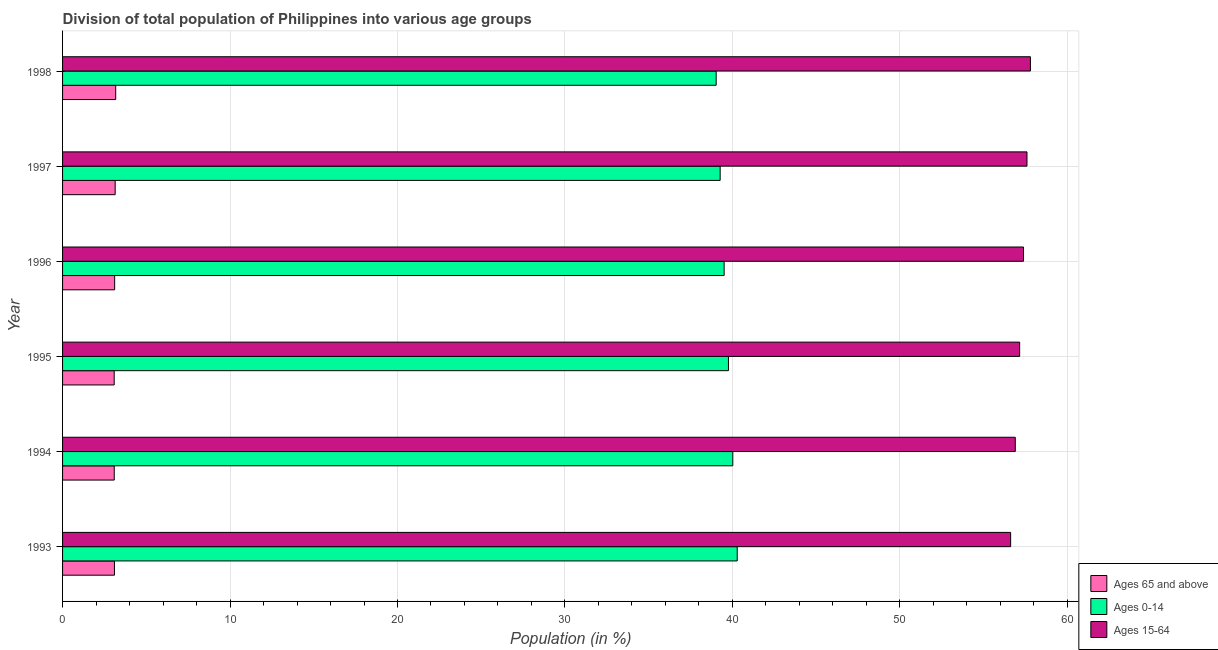How many different coloured bars are there?
Your answer should be very brief. 3. How many groups of bars are there?
Your answer should be very brief. 6. How many bars are there on the 1st tick from the top?
Your response must be concise. 3. How many bars are there on the 4th tick from the bottom?
Give a very brief answer. 3. What is the percentage of population within the age-group 15-64 in 1995?
Offer a very short reply. 57.15. Across all years, what is the maximum percentage of population within the age-group of 65 and above?
Offer a terse response. 3.17. Across all years, what is the minimum percentage of population within the age-group 0-14?
Offer a terse response. 39.03. In which year was the percentage of population within the age-group of 65 and above maximum?
Your answer should be compact. 1998. What is the total percentage of population within the age-group of 65 and above in the graph?
Give a very brief answer. 18.69. What is the difference between the percentage of population within the age-group 0-14 in 1994 and that in 1997?
Offer a terse response. 0.76. What is the difference between the percentage of population within the age-group 0-14 in 1998 and the percentage of population within the age-group of 65 and above in 1996?
Your response must be concise. 35.92. What is the average percentage of population within the age-group 0-14 per year?
Provide a succinct answer. 39.65. In the year 1995, what is the difference between the percentage of population within the age-group 0-14 and percentage of population within the age-group 15-64?
Offer a terse response. -17.39. In how many years, is the percentage of population within the age-group 15-64 greater than 54 %?
Your answer should be compact. 6. What is the ratio of the percentage of population within the age-group 15-64 in 1996 to that in 1998?
Provide a succinct answer. 0.99. Is the percentage of population within the age-group of 65 and above in 1993 less than that in 1995?
Your response must be concise. No. What is the difference between the highest and the second highest percentage of population within the age-group of 65 and above?
Provide a succinct answer. 0.03. What is the difference between the highest and the lowest percentage of population within the age-group of 65 and above?
Give a very brief answer. 0.09. Is the sum of the percentage of population within the age-group of 65 and above in 1996 and 1997 greater than the maximum percentage of population within the age-group 0-14 across all years?
Offer a very short reply. No. What does the 3rd bar from the top in 1994 represents?
Give a very brief answer. Ages 65 and above. What does the 2nd bar from the bottom in 1993 represents?
Your answer should be compact. Ages 0-14. What is the difference between two consecutive major ticks on the X-axis?
Keep it short and to the point. 10. Are the values on the major ticks of X-axis written in scientific E-notation?
Your response must be concise. No. Does the graph contain any zero values?
Offer a terse response. No. Where does the legend appear in the graph?
Provide a succinct answer. Bottom right. How many legend labels are there?
Ensure brevity in your answer.  3. What is the title of the graph?
Offer a terse response. Division of total population of Philippines into various age groups
. Does "Tertiary education" appear as one of the legend labels in the graph?
Your response must be concise. No. What is the label or title of the X-axis?
Keep it short and to the point. Population (in %). What is the label or title of the Y-axis?
Make the answer very short. Year. What is the Population (in %) of Ages 65 and above in 1993?
Offer a terse response. 3.1. What is the Population (in %) of Ages 0-14 in 1993?
Your answer should be compact. 40.29. What is the Population (in %) of Ages 15-64 in 1993?
Your answer should be very brief. 56.61. What is the Population (in %) in Ages 65 and above in 1994?
Keep it short and to the point. 3.09. What is the Population (in %) of Ages 0-14 in 1994?
Provide a succinct answer. 40.02. What is the Population (in %) of Ages 15-64 in 1994?
Provide a short and direct response. 56.89. What is the Population (in %) in Ages 65 and above in 1995?
Your response must be concise. 3.08. What is the Population (in %) of Ages 0-14 in 1995?
Your answer should be compact. 39.76. What is the Population (in %) in Ages 15-64 in 1995?
Ensure brevity in your answer.  57.15. What is the Population (in %) of Ages 65 and above in 1996?
Your answer should be very brief. 3.11. What is the Population (in %) of Ages 0-14 in 1996?
Your response must be concise. 39.51. What is the Population (in %) of Ages 15-64 in 1996?
Keep it short and to the point. 57.38. What is the Population (in %) of Ages 65 and above in 1997?
Your answer should be compact. 3.14. What is the Population (in %) of Ages 0-14 in 1997?
Provide a short and direct response. 39.27. What is the Population (in %) in Ages 15-64 in 1997?
Offer a terse response. 57.59. What is the Population (in %) in Ages 65 and above in 1998?
Keep it short and to the point. 3.17. What is the Population (in %) in Ages 0-14 in 1998?
Your answer should be compact. 39.03. What is the Population (in %) in Ages 15-64 in 1998?
Your response must be concise. 57.8. Across all years, what is the maximum Population (in %) in Ages 65 and above?
Provide a succinct answer. 3.17. Across all years, what is the maximum Population (in %) of Ages 0-14?
Offer a very short reply. 40.29. Across all years, what is the maximum Population (in %) of Ages 15-64?
Your answer should be compact. 57.8. Across all years, what is the minimum Population (in %) in Ages 65 and above?
Your answer should be very brief. 3.08. Across all years, what is the minimum Population (in %) in Ages 0-14?
Make the answer very short. 39.03. Across all years, what is the minimum Population (in %) in Ages 15-64?
Make the answer very short. 56.61. What is the total Population (in %) of Ages 65 and above in the graph?
Provide a short and direct response. 18.69. What is the total Population (in %) of Ages 0-14 in the graph?
Offer a terse response. 237.88. What is the total Population (in %) in Ages 15-64 in the graph?
Offer a terse response. 343.43. What is the difference between the Population (in %) of Ages 65 and above in 1993 and that in 1994?
Provide a succinct answer. 0.01. What is the difference between the Population (in %) in Ages 0-14 in 1993 and that in 1994?
Your answer should be compact. 0.26. What is the difference between the Population (in %) in Ages 15-64 in 1993 and that in 1994?
Provide a succinct answer. -0.28. What is the difference between the Population (in %) of Ages 65 and above in 1993 and that in 1995?
Offer a very short reply. 0.02. What is the difference between the Population (in %) of Ages 0-14 in 1993 and that in 1995?
Offer a terse response. 0.52. What is the difference between the Population (in %) of Ages 15-64 in 1993 and that in 1995?
Ensure brevity in your answer.  -0.54. What is the difference between the Population (in %) in Ages 65 and above in 1993 and that in 1996?
Provide a succinct answer. -0.01. What is the difference between the Population (in %) of Ages 0-14 in 1993 and that in 1996?
Your response must be concise. 0.78. What is the difference between the Population (in %) of Ages 15-64 in 1993 and that in 1996?
Your answer should be compact. -0.77. What is the difference between the Population (in %) of Ages 65 and above in 1993 and that in 1997?
Offer a terse response. -0.04. What is the difference between the Population (in %) of Ages 0-14 in 1993 and that in 1997?
Ensure brevity in your answer.  1.02. What is the difference between the Population (in %) in Ages 15-64 in 1993 and that in 1997?
Your answer should be compact. -0.98. What is the difference between the Population (in %) in Ages 65 and above in 1993 and that in 1998?
Make the answer very short. -0.07. What is the difference between the Population (in %) in Ages 0-14 in 1993 and that in 1998?
Offer a very short reply. 1.26. What is the difference between the Population (in %) in Ages 15-64 in 1993 and that in 1998?
Offer a very short reply. -1.18. What is the difference between the Population (in %) in Ages 65 and above in 1994 and that in 1995?
Give a very brief answer. 0. What is the difference between the Population (in %) in Ages 0-14 in 1994 and that in 1995?
Offer a very short reply. 0.26. What is the difference between the Population (in %) in Ages 15-64 in 1994 and that in 1995?
Offer a very short reply. -0.26. What is the difference between the Population (in %) of Ages 65 and above in 1994 and that in 1996?
Offer a terse response. -0.02. What is the difference between the Population (in %) in Ages 0-14 in 1994 and that in 1996?
Offer a very short reply. 0.52. What is the difference between the Population (in %) of Ages 15-64 in 1994 and that in 1996?
Ensure brevity in your answer.  -0.49. What is the difference between the Population (in %) of Ages 65 and above in 1994 and that in 1997?
Give a very brief answer. -0.06. What is the difference between the Population (in %) of Ages 0-14 in 1994 and that in 1997?
Keep it short and to the point. 0.75. What is the difference between the Population (in %) in Ages 15-64 in 1994 and that in 1997?
Your answer should be compact. -0.7. What is the difference between the Population (in %) of Ages 65 and above in 1994 and that in 1998?
Make the answer very short. -0.09. What is the difference between the Population (in %) in Ages 15-64 in 1994 and that in 1998?
Your answer should be very brief. -0.9. What is the difference between the Population (in %) of Ages 65 and above in 1995 and that in 1996?
Keep it short and to the point. -0.03. What is the difference between the Population (in %) in Ages 0-14 in 1995 and that in 1996?
Your response must be concise. 0.26. What is the difference between the Population (in %) in Ages 15-64 in 1995 and that in 1996?
Keep it short and to the point. -0.23. What is the difference between the Population (in %) in Ages 65 and above in 1995 and that in 1997?
Offer a very short reply. -0.06. What is the difference between the Population (in %) in Ages 0-14 in 1995 and that in 1997?
Your answer should be very brief. 0.5. What is the difference between the Population (in %) of Ages 15-64 in 1995 and that in 1997?
Ensure brevity in your answer.  -0.44. What is the difference between the Population (in %) of Ages 65 and above in 1995 and that in 1998?
Offer a terse response. -0.09. What is the difference between the Population (in %) in Ages 0-14 in 1995 and that in 1998?
Ensure brevity in your answer.  0.73. What is the difference between the Population (in %) in Ages 15-64 in 1995 and that in 1998?
Ensure brevity in your answer.  -0.64. What is the difference between the Population (in %) of Ages 65 and above in 1996 and that in 1997?
Make the answer very short. -0.03. What is the difference between the Population (in %) in Ages 0-14 in 1996 and that in 1997?
Ensure brevity in your answer.  0.24. What is the difference between the Population (in %) in Ages 15-64 in 1996 and that in 1997?
Your answer should be very brief. -0.21. What is the difference between the Population (in %) in Ages 65 and above in 1996 and that in 1998?
Ensure brevity in your answer.  -0.06. What is the difference between the Population (in %) in Ages 0-14 in 1996 and that in 1998?
Give a very brief answer. 0.48. What is the difference between the Population (in %) in Ages 15-64 in 1996 and that in 1998?
Offer a very short reply. -0.41. What is the difference between the Population (in %) in Ages 65 and above in 1997 and that in 1998?
Give a very brief answer. -0.03. What is the difference between the Population (in %) in Ages 0-14 in 1997 and that in 1998?
Your answer should be compact. 0.24. What is the difference between the Population (in %) of Ages 15-64 in 1997 and that in 1998?
Your answer should be very brief. -0.21. What is the difference between the Population (in %) of Ages 65 and above in 1993 and the Population (in %) of Ages 0-14 in 1994?
Your answer should be very brief. -36.92. What is the difference between the Population (in %) in Ages 65 and above in 1993 and the Population (in %) in Ages 15-64 in 1994?
Offer a terse response. -53.79. What is the difference between the Population (in %) in Ages 0-14 in 1993 and the Population (in %) in Ages 15-64 in 1994?
Your response must be concise. -16.6. What is the difference between the Population (in %) in Ages 65 and above in 1993 and the Population (in %) in Ages 0-14 in 1995?
Your answer should be very brief. -36.66. What is the difference between the Population (in %) in Ages 65 and above in 1993 and the Population (in %) in Ages 15-64 in 1995?
Offer a very short reply. -54.05. What is the difference between the Population (in %) of Ages 0-14 in 1993 and the Population (in %) of Ages 15-64 in 1995?
Give a very brief answer. -16.87. What is the difference between the Population (in %) of Ages 65 and above in 1993 and the Population (in %) of Ages 0-14 in 1996?
Provide a succinct answer. -36.41. What is the difference between the Population (in %) in Ages 65 and above in 1993 and the Population (in %) in Ages 15-64 in 1996?
Your response must be concise. -54.28. What is the difference between the Population (in %) of Ages 0-14 in 1993 and the Population (in %) of Ages 15-64 in 1996?
Offer a terse response. -17.1. What is the difference between the Population (in %) in Ages 65 and above in 1993 and the Population (in %) in Ages 0-14 in 1997?
Keep it short and to the point. -36.17. What is the difference between the Population (in %) in Ages 65 and above in 1993 and the Population (in %) in Ages 15-64 in 1997?
Your answer should be compact. -54.49. What is the difference between the Population (in %) in Ages 0-14 in 1993 and the Population (in %) in Ages 15-64 in 1997?
Provide a succinct answer. -17.3. What is the difference between the Population (in %) of Ages 65 and above in 1993 and the Population (in %) of Ages 0-14 in 1998?
Offer a very short reply. -35.93. What is the difference between the Population (in %) of Ages 65 and above in 1993 and the Population (in %) of Ages 15-64 in 1998?
Your answer should be compact. -54.7. What is the difference between the Population (in %) in Ages 0-14 in 1993 and the Population (in %) in Ages 15-64 in 1998?
Give a very brief answer. -17.51. What is the difference between the Population (in %) in Ages 65 and above in 1994 and the Population (in %) in Ages 0-14 in 1995?
Provide a short and direct response. -36.68. What is the difference between the Population (in %) in Ages 65 and above in 1994 and the Population (in %) in Ages 15-64 in 1995?
Your answer should be very brief. -54.07. What is the difference between the Population (in %) in Ages 0-14 in 1994 and the Population (in %) in Ages 15-64 in 1995?
Make the answer very short. -17.13. What is the difference between the Population (in %) of Ages 65 and above in 1994 and the Population (in %) of Ages 0-14 in 1996?
Keep it short and to the point. -36.42. What is the difference between the Population (in %) of Ages 65 and above in 1994 and the Population (in %) of Ages 15-64 in 1996?
Provide a short and direct response. -54.3. What is the difference between the Population (in %) in Ages 0-14 in 1994 and the Population (in %) in Ages 15-64 in 1996?
Give a very brief answer. -17.36. What is the difference between the Population (in %) of Ages 65 and above in 1994 and the Population (in %) of Ages 0-14 in 1997?
Your response must be concise. -36.18. What is the difference between the Population (in %) in Ages 65 and above in 1994 and the Population (in %) in Ages 15-64 in 1997?
Provide a short and direct response. -54.5. What is the difference between the Population (in %) of Ages 0-14 in 1994 and the Population (in %) of Ages 15-64 in 1997?
Provide a short and direct response. -17.57. What is the difference between the Population (in %) in Ages 65 and above in 1994 and the Population (in %) in Ages 0-14 in 1998?
Offer a very short reply. -35.94. What is the difference between the Population (in %) in Ages 65 and above in 1994 and the Population (in %) in Ages 15-64 in 1998?
Provide a short and direct response. -54.71. What is the difference between the Population (in %) in Ages 0-14 in 1994 and the Population (in %) in Ages 15-64 in 1998?
Offer a very short reply. -17.77. What is the difference between the Population (in %) in Ages 65 and above in 1995 and the Population (in %) in Ages 0-14 in 1996?
Provide a succinct answer. -36.42. What is the difference between the Population (in %) of Ages 65 and above in 1995 and the Population (in %) of Ages 15-64 in 1996?
Your answer should be compact. -54.3. What is the difference between the Population (in %) of Ages 0-14 in 1995 and the Population (in %) of Ages 15-64 in 1996?
Your response must be concise. -17.62. What is the difference between the Population (in %) of Ages 65 and above in 1995 and the Population (in %) of Ages 0-14 in 1997?
Make the answer very short. -36.18. What is the difference between the Population (in %) of Ages 65 and above in 1995 and the Population (in %) of Ages 15-64 in 1997?
Provide a succinct answer. -54.51. What is the difference between the Population (in %) of Ages 0-14 in 1995 and the Population (in %) of Ages 15-64 in 1997?
Your response must be concise. -17.83. What is the difference between the Population (in %) in Ages 65 and above in 1995 and the Population (in %) in Ages 0-14 in 1998?
Make the answer very short. -35.95. What is the difference between the Population (in %) in Ages 65 and above in 1995 and the Population (in %) in Ages 15-64 in 1998?
Your answer should be compact. -54.71. What is the difference between the Population (in %) in Ages 0-14 in 1995 and the Population (in %) in Ages 15-64 in 1998?
Give a very brief answer. -18.03. What is the difference between the Population (in %) of Ages 65 and above in 1996 and the Population (in %) of Ages 0-14 in 1997?
Ensure brevity in your answer.  -36.16. What is the difference between the Population (in %) in Ages 65 and above in 1996 and the Population (in %) in Ages 15-64 in 1997?
Your response must be concise. -54.48. What is the difference between the Population (in %) in Ages 0-14 in 1996 and the Population (in %) in Ages 15-64 in 1997?
Your answer should be very brief. -18.08. What is the difference between the Population (in %) in Ages 65 and above in 1996 and the Population (in %) in Ages 0-14 in 1998?
Offer a very short reply. -35.92. What is the difference between the Population (in %) in Ages 65 and above in 1996 and the Population (in %) in Ages 15-64 in 1998?
Provide a short and direct response. -54.69. What is the difference between the Population (in %) of Ages 0-14 in 1996 and the Population (in %) of Ages 15-64 in 1998?
Make the answer very short. -18.29. What is the difference between the Population (in %) in Ages 65 and above in 1997 and the Population (in %) in Ages 0-14 in 1998?
Offer a terse response. -35.89. What is the difference between the Population (in %) of Ages 65 and above in 1997 and the Population (in %) of Ages 15-64 in 1998?
Give a very brief answer. -54.65. What is the difference between the Population (in %) of Ages 0-14 in 1997 and the Population (in %) of Ages 15-64 in 1998?
Make the answer very short. -18.53. What is the average Population (in %) of Ages 65 and above per year?
Your answer should be compact. 3.12. What is the average Population (in %) in Ages 0-14 per year?
Offer a terse response. 39.65. What is the average Population (in %) in Ages 15-64 per year?
Offer a very short reply. 57.24. In the year 1993, what is the difference between the Population (in %) of Ages 65 and above and Population (in %) of Ages 0-14?
Your response must be concise. -37.19. In the year 1993, what is the difference between the Population (in %) of Ages 65 and above and Population (in %) of Ages 15-64?
Your response must be concise. -53.52. In the year 1993, what is the difference between the Population (in %) of Ages 0-14 and Population (in %) of Ages 15-64?
Your answer should be compact. -16.33. In the year 1994, what is the difference between the Population (in %) in Ages 65 and above and Population (in %) in Ages 0-14?
Make the answer very short. -36.94. In the year 1994, what is the difference between the Population (in %) of Ages 65 and above and Population (in %) of Ages 15-64?
Give a very brief answer. -53.81. In the year 1994, what is the difference between the Population (in %) in Ages 0-14 and Population (in %) in Ages 15-64?
Your answer should be very brief. -16.87. In the year 1995, what is the difference between the Population (in %) of Ages 65 and above and Population (in %) of Ages 0-14?
Your response must be concise. -36.68. In the year 1995, what is the difference between the Population (in %) of Ages 65 and above and Population (in %) of Ages 15-64?
Ensure brevity in your answer.  -54.07. In the year 1995, what is the difference between the Population (in %) of Ages 0-14 and Population (in %) of Ages 15-64?
Your response must be concise. -17.39. In the year 1996, what is the difference between the Population (in %) of Ages 65 and above and Population (in %) of Ages 0-14?
Offer a very short reply. -36.39. In the year 1996, what is the difference between the Population (in %) in Ages 65 and above and Population (in %) in Ages 15-64?
Your answer should be very brief. -54.27. In the year 1996, what is the difference between the Population (in %) in Ages 0-14 and Population (in %) in Ages 15-64?
Offer a terse response. -17.88. In the year 1997, what is the difference between the Population (in %) in Ages 65 and above and Population (in %) in Ages 0-14?
Your answer should be compact. -36.13. In the year 1997, what is the difference between the Population (in %) in Ages 65 and above and Population (in %) in Ages 15-64?
Your answer should be very brief. -54.45. In the year 1997, what is the difference between the Population (in %) in Ages 0-14 and Population (in %) in Ages 15-64?
Your answer should be very brief. -18.32. In the year 1998, what is the difference between the Population (in %) of Ages 65 and above and Population (in %) of Ages 0-14?
Keep it short and to the point. -35.86. In the year 1998, what is the difference between the Population (in %) in Ages 65 and above and Population (in %) in Ages 15-64?
Provide a short and direct response. -54.62. In the year 1998, what is the difference between the Population (in %) in Ages 0-14 and Population (in %) in Ages 15-64?
Offer a very short reply. -18.77. What is the ratio of the Population (in %) in Ages 0-14 in 1993 to that in 1994?
Offer a very short reply. 1.01. What is the ratio of the Population (in %) in Ages 65 and above in 1993 to that in 1995?
Your response must be concise. 1. What is the ratio of the Population (in %) in Ages 0-14 in 1993 to that in 1995?
Give a very brief answer. 1.01. What is the ratio of the Population (in %) of Ages 15-64 in 1993 to that in 1995?
Your response must be concise. 0.99. What is the ratio of the Population (in %) in Ages 65 and above in 1993 to that in 1996?
Your answer should be compact. 1. What is the ratio of the Population (in %) in Ages 0-14 in 1993 to that in 1996?
Give a very brief answer. 1.02. What is the ratio of the Population (in %) in Ages 15-64 in 1993 to that in 1996?
Your answer should be compact. 0.99. What is the ratio of the Population (in %) in Ages 65 and above in 1993 to that in 1997?
Provide a short and direct response. 0.99. What is the ratio of the Population (in %) in Ages 0-14 in 1993 to that in 1997?
Your answer should be compact. 1.03. What is the ratio of the Population (in %) in Ages 15-64 in 1993 to that in 1997?
Ensure brevity in your answer.  0.98. What is the ratio of the Population (in %) in Ages 65 and above in 1993 to that in 1998?
Offer a terse response. 0.98. What is the ratio of the Population (in %) in Ages 0-14 in 1993 to that in 1998?
Your answer should be very brief. 1.03. What is the ratio of the Population (in %) of Ages 15-64 in 1993 to that in 1998?
Give a very brief answer. 0.98. What is the ratio of the Population (in %) of Ages 0-14 in 1994 to that in 1995?
Offer a very short reply. 1.01. What is the ratio of the Population (in %) of Ages 15-64 in 1994 to that in 1995?
Your answer should be compact. 1. What is the ratio of the Population (in %) in Ages 65 and above in 1994 to that in 1996?
Offer a terse response. 0.99. What is the ratio of the Population (in %) in Ages 0-14 in 1994 to that in 1996?
Offer a terse response. 1.01. What is the ratio of the Population (in %) of Ages 15-64 in 1994 to that in 1996?
Your response must be concise. 0.99. What is the ratio of the Population (in %) in Ages 65 and above in 1994 to that in 1997?
Provide a succinct answer. 0.98. What is the ratio of the Population (in %) in Ages 0-14 in 1994 to that in 1997?
Provide a short and direct response. 1.02. What is the ratio of the Population (in %) of Ages 15-64 in 1994 to that in 1997?
Give a very brief answer. 0.99. What is the ratio of the Population (in %) of Ages 65 and above in 1994 to that in 1998?
Your answer should be compact. 0.97. What is the ratio of the Population (in %) in Ages 0-14 in 1994 to that in 1998?
Offer a very short reply. 1.03. What is the ratio of the Population (in %) of Ages 15-64 in 1994 to that in 1998?
Your response must be concise. 0.98. What is the ratio of the Population (in %) of Ages 0-14 in 1995 to that in 1996?
Ensure brevity in your answer.  1.01. What is the ratio of the Population (in %) of Ages 65 and above in 1995 to that in 1997?
Your response must be concise. 0.98. What is the ratio of the Population (in %) in Ages 0-14 in 1995 to that in 1997?
Ensure brevity in your answer.  1.01. What is the ratio of the Population (in %) of Ages 65 and above in 1995 to that in 1998?
Your response must be concise. 0.97. What is the ratio of the Population (in %) of Ages 0-14 in 1995 to that in 1998?
Provide a succinct answer. 1.02. What is the ratio of the Population (in %) of Ages 15-64 in 1995 to that in 1998?
Provide a succinct answer. 0.99. What is the ratio of the Population (in %) of Ages 65 and above in 1996 to that in 1997?
Offer a very short reply. 0.99. What is the ratio of the Population (in %) of Ages 0-14 in 1996 to that in 1997?
Provide a short and direct response. 1.01. What is the ratio of the Population (in %) of Ages 15-64 in 1996 to that in 1997?
Your response must be concise. 1. What is the ratio of the Population (in %) of Ages 65 and above in 1996 to that in 1998?
Provide a succinct answer. 0.98. What is the ratio of the Population (in %) in Ages 0-14 in 1996 to that in 1998?
Offer a terse response. 1.01. What is the ratio of the Population (in %) in Ages 15-64 in 1997 to that in 1998?
Offer a terse response. 1. What is the difference between the highest and the second highest Population (in %) of Ages 65 and above?
Your answer should be very brief. 0.03. What is the difference between the highest and the second highest Population (in %) in Ages 0-14?
Keep it short and to the point. 0.26. What is the difference between the highest and the second highest Population (in %) of Ages 15-64?
Keep it short and to the point. 0.21. What is the difference between the highest and the lowest Population (in %) in Ages 65 and above?
Keep it short and to the point. 0.09. What is the difference between the highest and the lowest Population (in %) in Ages 0-14?
Provide a short and direct response. 1.26. What is the difference between the highest and the lowest Population (in %) of Ages 15-64?
Your answer should be compact. 1.18. 